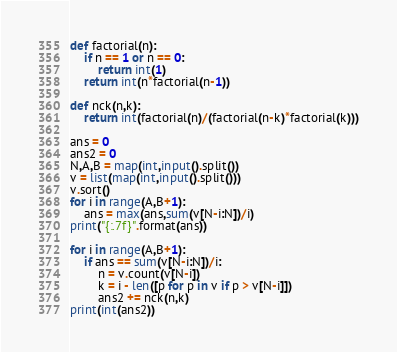Convert code to text. <code><loc_0><loc_0><loc_500><loc_500><_Python_>def factorial(n):
    if n == 1 or n == 0:
        return int(1)
    return int(n*factorial(n-1))

def nck(n,k):
    return int(factorial(n)/(factorial(n-k)*factorial(k)))

ans = 0
ans2 = 0
N,A,B = map(int,input().split())
v = list(map(int,input().split()))
v.sort()
for i in range(A,B+1):
    ans = max(ans,sum(v[N-i:N])/i)
print("{:.7f}".format(ans))

for i in range(A,B+1):
    if ans == sum(v[N-i:N])/i:
        n = v.count(v[N-i])
        k = i - len([p for p in v if p > v[N-i]])
        ans2 += nck(n,k)
print(int(ans2))
</code> 